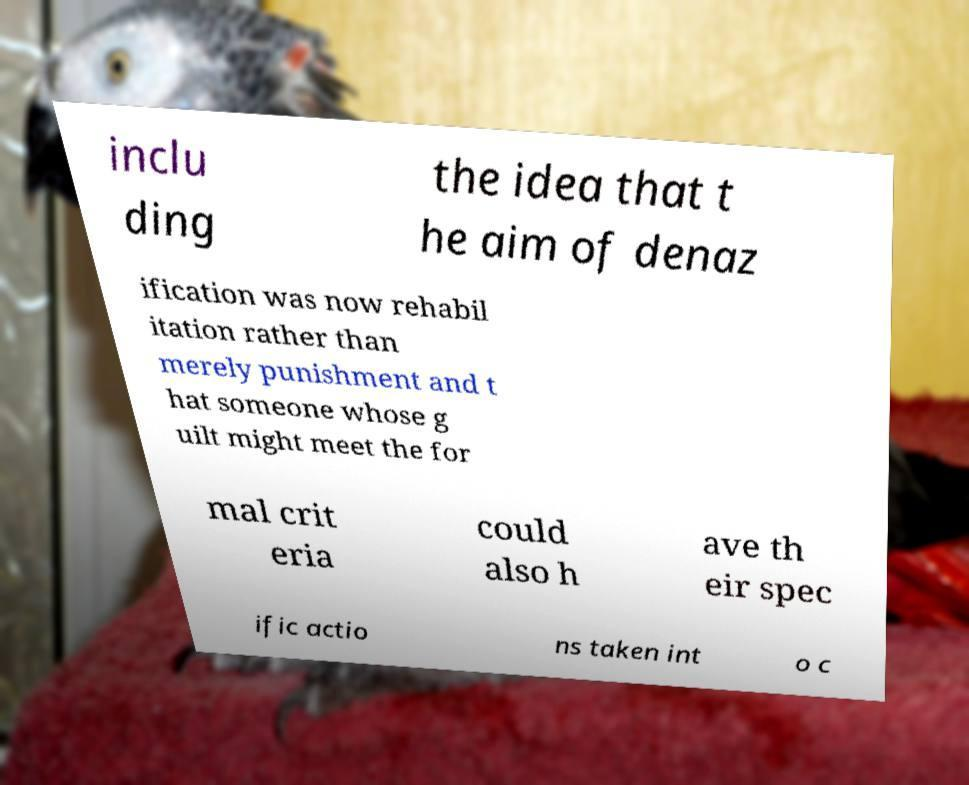What messages or text are displayed in this image? I need them in a readable, typed format. inclu ding the idea that t he aim of denaz ification was now rehabil itation rather than merely punishment and t hat someone whose g uilt might meet the for mal crit eria could also h ave th eir spec ific actio ns taken int o c 